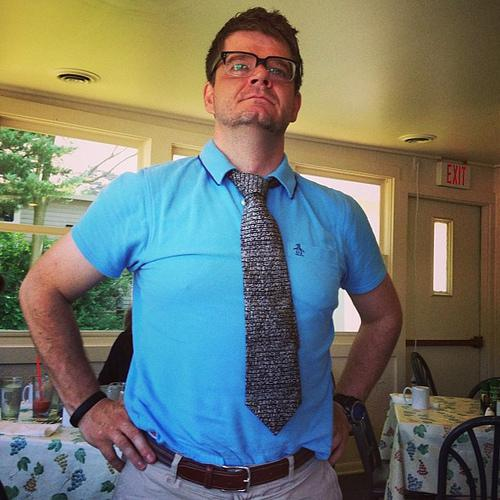Question: when kind of sign is above the door?
Choices:
A. Enter.
B. Exit.
C. No entry.
D. Emergency Exit.
Answer with the letter. Answer: B Question: what color belt is the man wearing?
Choices:
A. Black.
B. Brown.
C. Yellow.
D. Blue.
Answer with the letter. Answer: B Question: where was the photo taken?
Choices:
A. Restaurant.
B. At a school.
C. At a house.
D. Outside.
Answer with the letter. Answer: A Question: where are the man's hands?
Choices:
A. In his pockets.
B. At his side.
C. On his head.
D. On his hips.
Answer with the letter. Answer: D Question: what is on the man's left wrist?
Choices:
A. A bracelet.
B. A tattoo.
C. A rubber band.
D. A watch.
Answer with the letter. Answer: D 